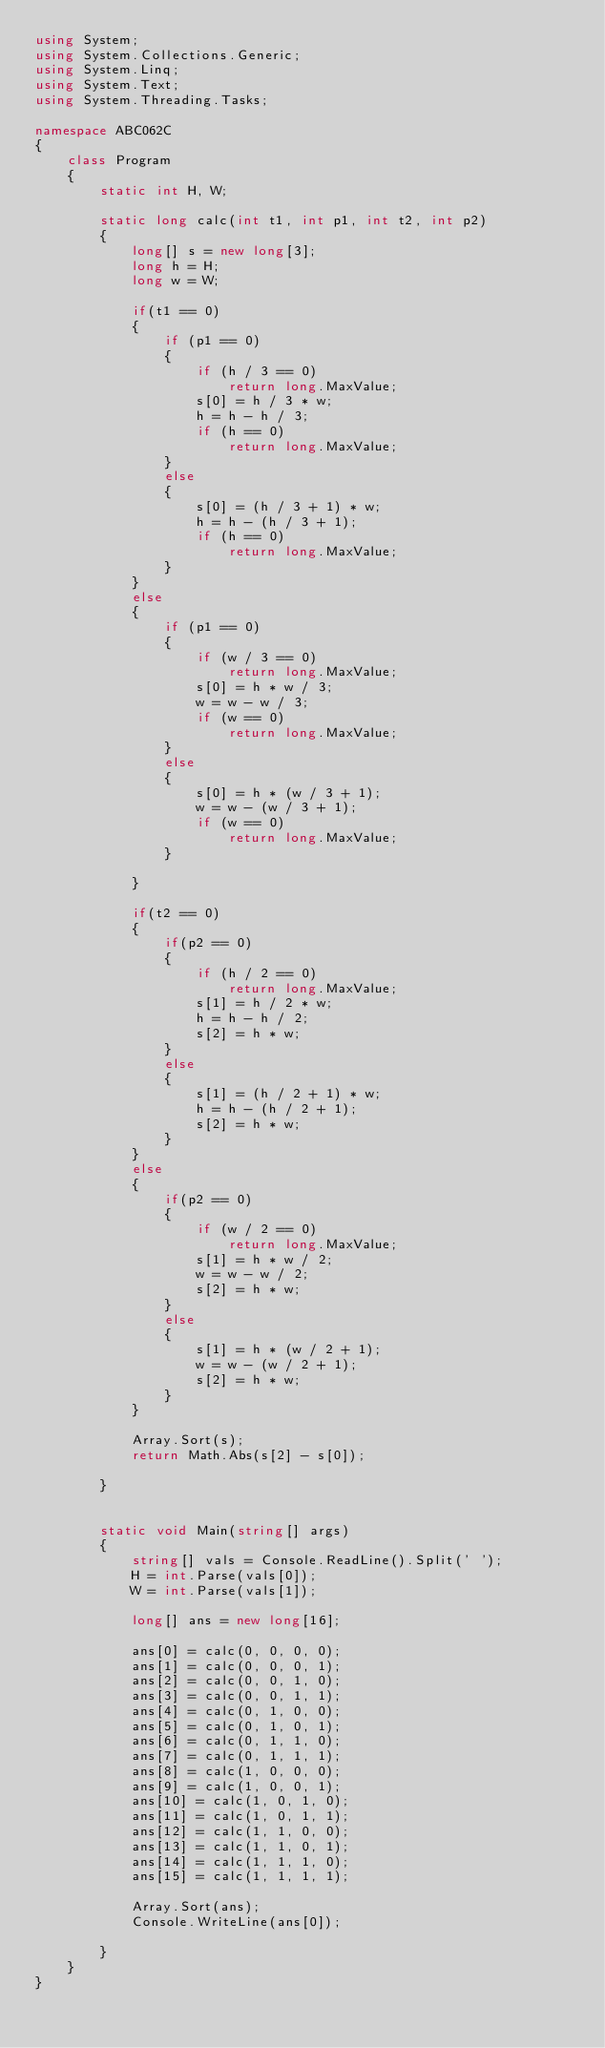<code> <loc_0><loc_0><loc_500><loc_500><_C#_>using System;
using System.Collections.Generic;
using System.Linq;
using System.Text;
using System.Threading.Tasks;

namespace ABC062C
{
    class Program
    {
        static int H, W;

        static long calc(int t1, int p1, int t2, int p2)
        {
            long[] s = new long[3];
            long h = H;
            long w = W;
            
            if(t1 == 0)
            {
                if (p1 == 0)
                {
                    if (h / 3 == 0)
                        return long.MaxValue;
                    s[0] = h / 3 * w;
                    h = h - h / 3;
                    if (h == 0)
                        return long.MaxValue;
                }
                else
                {
                    s[0] = (h / 3 + 1) * w;
                    h = h - (h / 3 + 1);
                    if (h == 0)
                        return long.MaxValue;
                }
            }
            else
            {
                if (p1 == 0)
                {
                    if (w / 3 == 0)
                        return long.MaxValue;
                    s[0] = h * w / 3;
                    w = w - w / 3;
                    if (w == 0)
                        return long.MaxValue;
                }
                else
                {
                    s[0] = h * (w / 3 + 1);
                    w = w - (w / 3 + 1);
                    if (w == 0)
                        return long.MaxValue;
                }

            }

            if(t2 == 0)
            {
                if(p2 == 0)
                {
                    if (h / 2 == 0)
                        return long.MaxValue;
                    s[1] = h / 2 * w;
                    h = h - h / 2;
                    s[2] = h * w;
                }
                else
                {
                    s[1] = (h / 2 + 1) * w;
                    h = h - (h / 2 + 1);
                    s[2] = h * w;
                }
            }
            else
            {
                if(p2 == 0)
                {
                    if (w / 2 == 0)
                        return long.MaxValue;
                    s[1] = h * w / 2;
                    w = w - w / 2;
                    s[2] = h * w;
                }
                else
                {
                    s[1] = h * (w / 2 + 1);
                    w = w - (w / 2 + 1);
                    s[2] = h * w;
                }
            }

            Array.Sort(s);
            return Math.Abs(s[2] - s[0]);

        }


        static void Main(string[] args)
        {
            string[] vals = Console.ReadLine().Split(' ');
            H = int.Parse(vals[0]);
            W = int.Parse(vals[1]);

            long[] ans = new long[16];

            ans[0] = calc(0, 0, 0, 0);
            ans[1] = calc(0, 0, 0, 1);
            ans[2] = calc(0, 0, 1, 0);
            ans[3] = calc(0, 0, 1, 1);
            ans[4] = calc(0, 1, 0, 0);
            ans[5] = calc(0, 1, 0, 1);
            ans[6] = calc(0, 1, 1, 0);
            ans[7] = calc(0, 1, 1, 1);
            ans[8] = calc(1, 0, 0, 0);
            ans[9] = calc(1, 0, 0, 1);
            ans[10] = calc(1, 0, 1, 0);
            ans[11] = calc(1, 0, 1, 1);
            ans[12] = calc(1, 1, 0, 0);
            ans[13] = calc(1, 1, 0, 1);
            ans[14] = calc(1, 1, 1, 0);
            ans[15] = calc(1, 1, 1, 1);

            Array.Sort(ans);
            Console.WriteLine(ans[0]);

        }
    }
}
</code> 